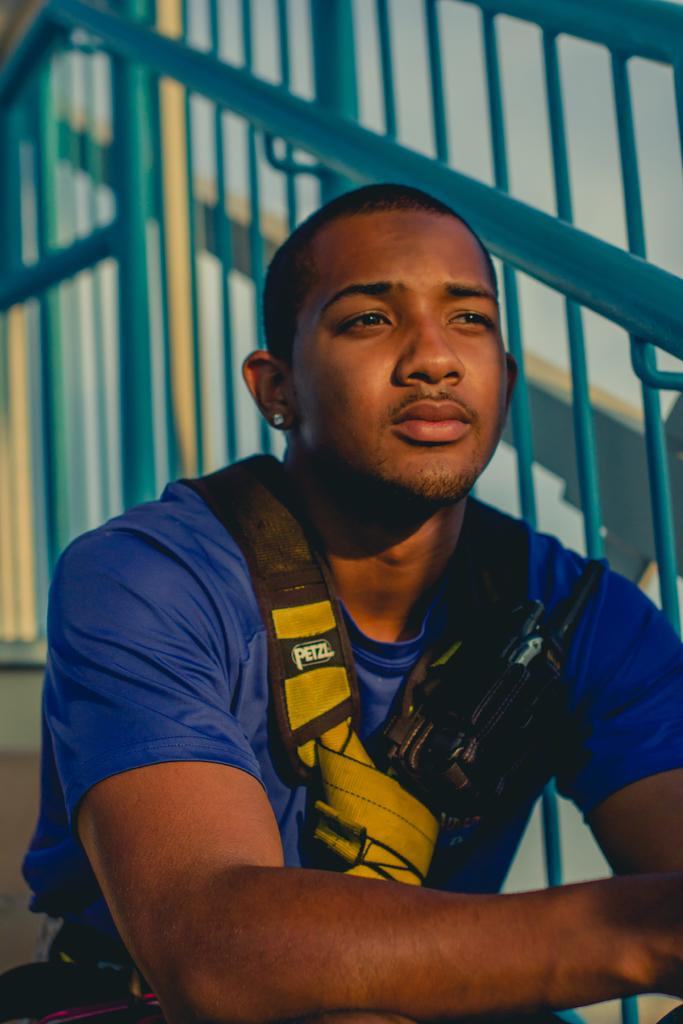What is the man in the image doing? The man is sitting in the image. What can be seen in the background of the image? There are iron grills in the background of the image. What type of underwear is the man wearing in the image? There is no information about the man's underwear in the image, so it cannot be determined. 